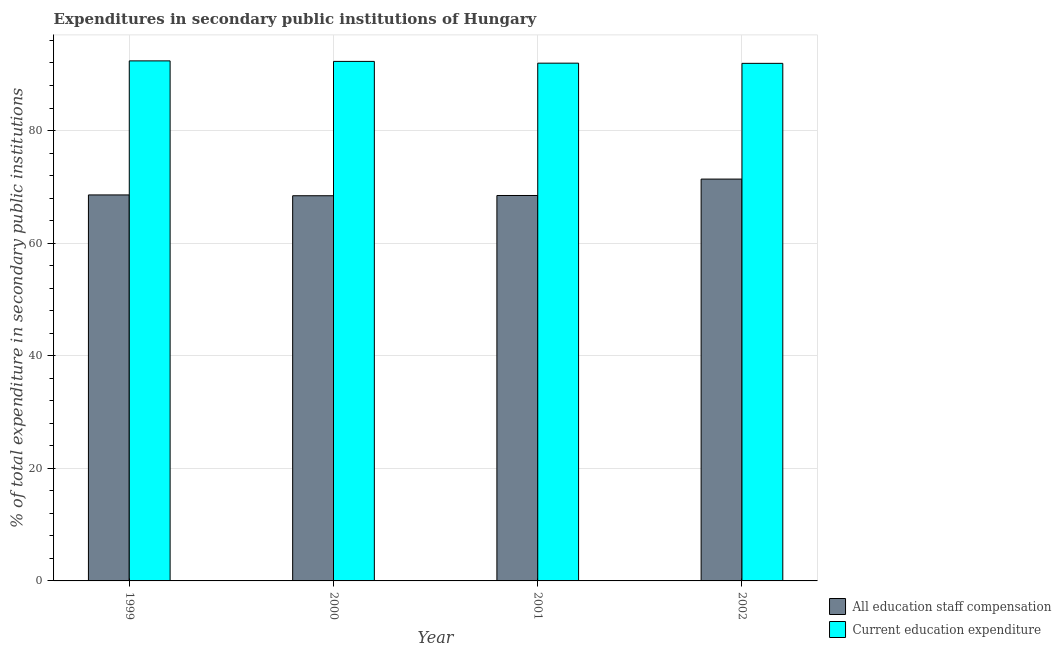How many different coloured bars are there?
Ensure brevity in your answer.  2. How many groups of bars are there?
Give a very brief answer. 4. How many bars are there on the 1st tick from the left?
Provide a succinct answer. 2. How many bars are there on the 1st tick from the right?
Provide a succinct answer. 2. What is the label of the 1st group of bars from the left?
Your answer should be very brief. 1999. In how many cases, is the number of bars for a given year not equal to the number of legend labels?
Your answer should be very brief. 0. What is the expenditure in staff compensation in 2001?
Offer a terse response. 68.46. Across all years, what is the maximum expenditure in staff compensation?
Ensure brevity in your answer.  71.38. Across all years, what is the minimum expenditure in staff compensation?
Provide a short and direct response. 68.42. What is the total expenditure in staff compensation in the graph?
Offer a very short reply. 276.83. What is the difference between the expenditure in education in 1999 and that in 2001?
Your response must be concise. 0.41. What is the difference between the expenditure in staff compensation in 2000 and the expenditure in education in 2001?
Keep it short and to the point. -0.04. What is the average expenditure in education per year?
Provide a short and direct response. 92.14. In the year 2001, what is the difference between the expenditure in staff compensation and expenditure in education?
Offer a terse response. 0. What is the ratio of the expenditure in staff compensation in 1999 to that in 2002?
Keep it short and to the point. 0.96. Is the difference between the expenditure in staff compensation in 1999 and 2001 greater than the difference between the expenditure in education in 1999 and 2001?
Offer a very short reply. No. What is the difference between the highest and the second highest expenditure in staff compensation?
Give a very brief answer. 2.81. What is the difference between the highest and the lowest expenditure in staff compensation?
Ensure brevity in your answer.  2.96. What does the 1st bar from the left in 1999 represents?
Make the answer very short. All education staff compensation. What does the 2nd bar from the right in 1999 represents?
Your answer should be compact. All education staff compensation. How many years are there in the graph?
Offer a very short reply. 4. Does the graph contain any zero values?
Offer a terse response. No. Does the graph contain grids?
Provide a succinct answer. Yes. How are the legend labels stacked?
Make the answer very short. Vertical. What is the title of the graph?
Give a very brief answer. Expenditures in secondary public institutions of Hungary. What is the label or title of the Y-axis?
Your response must be concise. % of total expenditure in secondary public institutions. What is the % of total expenditure in secondary public institutions of All education staff compensation in 1999?
Ensure brevity in your answer.  68.57. What is the % of total expenditure in secondary public institutions of Current education expenditure in 1999?
Offer a terse response. 92.38. What is the % of total expenditure in secondary public institutions in All education staff compensation in 2000?
Your answer should be compact. 68.42. What is the % of total expenditure in secondary public institutions in Current education expenditure in 2000?
Ensure brevity in your answer.  92.28. What is the % of total expenditure in secondary public institutions of All education staff compensation in 2001?
Make the answer very short. 68.46. What is the % of total expenditure in secondary public institutions of Current education expenditure in 2001?
Make the answer very short. 91.97. What is the % of total expenditure in secondary public institutions of All education staff compensation in 2002?
Make the answer very short. 71.38. What is the % of total expenditure in secondary public institutions of Current education expenditure in 2002?
Give a very brief answer. 91.94. Across all years, what is the maximum % of total expenditure in secondary public institutions in All education staff compensation?
Provide a succinct answer. 71.38. Across all years, what is the maximum % of total expenditure in secondary public institutions in Current education expenditure?
Offer a terse response. 92.38. Across all years, what is the minimum % of total expenditure in secondary public institutions in All education staff compensation?
Give a very brief answer. 68.42. Across all years, what is the minimum % of total expenditure in secondary public institutions in Current education expenditure?
Your answer should be compact. 91.94. What is the total % of total expenditure in secondary public institutions in All education staff compensation in the graph?
Keep it short and to the point. 276.83. What is the total % of total expenditure in secondary public institutions of Current education expenditure in the graph?
Your answer should be compact. 368.56. What is the difference between the % of total expenditure in secondary public institutions in All education staff compensation in 1999 and that in 2000?
Keep it short and to the point. 0.14. What is the difference between the % of total expenditure in secondary public institutions in Current education expenditure in 1999 and that in 2000?
Offer a terse response. 0.09. What is the difference between the % of total expenditure in secondary public institutions of All education staff compensation in 1999 and that in 2001?
Provide a succinct answer. 0.1. What is the difference between the % of total expenditure in secondary public institutions in Current education expenditure in 1999 and that in 2001?
Ensure brevity in your answer.  0.41. What is the difference between the % of total expenditure in secondary public institutions in All education staff compensation in 1999 and that in 2002?
Offer a very short reply. -2.81. What is the difference between the % of total expenditure in secondary public institutions in Current education expenditure in 1999 and that in 2002?
Make the answer very short. 0.44. What is the difference between the % of total expenditure in secondary public institutions of All education staff compensation in 2000 and that in 2001?
Your answer should be very brief. -0.04. What is the difference between the % of total expenditure in secondary public institutions in Current education expenditure in 2000 and that in 2001?
Give a very brief answer. 0.31. What is the difference between the % of total expenditure in secondary public institutions in All education staff compensation in 2000 and that in 2002?
Offer a very short reply. -2.96. What is the difference between the % of total expenditure in secondary public institutions of Current education expenditure in 2000 and that in 2002?
Offer a terse response. 0.35. What is the difference between the % of total expenditure in secondary public institutions of All education staff compensation in 2001 and that in 2002?
Give a very brief answer. -2.92. What is the difference between the % of total expenditure in secondary public institutions in Current education expenditure in 2001 and that in 2002?
Give a very brief answer. 0.03. What is the difference between the % of total expenditure in secondary public institutions in All education staff compensation in 1999 and the % of total expenditure in secondary public institutions in Current education expenditure in 2000?
Provide a succinct answer. -23.72. What is the difference between the % of total expenditure in secondary public institutions in All education staff compensation in 1999 and the % of total expenditure in secondary public institutions in Current education expenditure in 2001?
Ensure brevity in your answer.  -23.4. What is the difference between the % of total expenditure in secondary public institutions in All education staff compensation in 1999 and the % of total expenditure in secondary public institutions in Current education expenditure in 2002?
Ensure brevity in your answer.  -23.37. What is the difference between the % of total expenditure in secondary public institutions in All education staff compensation in 2000 and the % of total expenditure in secondary public institutions in Current education expenditure in 2001?
Your answer should be very brief. -23.55. What is the difference between the % of total expenditure in secondary public institutions in All education staff compensation in 2000 and the % of total expenditure in secondary public institutions in Current education expenditure in 2002?
Give a very brief answer. -23.51. What is the difference between the % of total expenditure in secondary public institutions of All education staff compensation in 2001 and the % of total expenditure in secondary public institutions of Current education expenditure in 2002?
Make the answer very short. -23.47. What is the average % of total expenditure in secondary public institutions in All education staff compensation per year?
Provide a short and direct response. 69.21. What is the average % of total expenditure in secondary public institutions in Current education expenditure per year?
Ensure brevity in your answer.  92.14. In the year 1999, what is the difference between the % of total expenditure in secondary public institutions of All education staff compensation and % of total expenditure in secondary public institutions of Current education expenditure?
Make the answer very short. -23.81. In the year 2000, what is the difference between the % of total expenditure in secondary public institutions of All education staff compensation and % of total expenditure in secondary public institutions of Current education expenditure?
Your answer should be compact. -23.86. In the year 2001, what is the difference between the % of total expenditure in secondary public institutions in All education staff compensation and % of total expenditure in secondary public institutions in Current education expenditure?
Your answer should be very brief. -23.51. In the year 2002, what is the difference between the % of total expenditure in secondary public institutions of All education staff compensation and % of total expenditure in secondary public institutions of Current education expenditure?
Make the answer very short. -20.56. What is the ratio of the % of total expenditure in secondary public institutions in All education staff compensation in 1999 to that in 2001?
Your answer should be very brief. 1. What is the ratio of the % of total expenditure in secondary public institutions of Current education expenditure in 1999 to that in 2001?
Offer a very short reply. 1. What is the ratio of the % of total expenditure in secondary public institutions of All education staff compensation in 1999 to that in 2002?
Your answer should be compact. 0.96. What is the ratio of the % of total expenditure in secondary public institutions of All education staff compensation in 2000 to that in 2001?
Provide a short and direct response. 1. What is the ratio of the % of total expenditure in secondary public institutions in Current education expenditure in 2000 to that in 2001?
Offer a terse response. 1. What is the ratio of the % of total expenditure in secondary public institutions in All education staff compensation in 2000 to that in 2002?
Your answer should be compact. 0.96. What is the ratio of the % of total expenditure in secondary public institutions of Current education expenditure in 2000 to that in 2002?
Your answer should be compact. 1. What is the ratio of the % of total expenditure in secondary public institutions of All education staff compensation in 2001 to that in 2002?
Offer a terse response. 0.96. What is the difference between the highest and the second highest % of total expenditure in secondary public institutions of All education staff compensation?
Your answer should be very brief. 2.81. What is the difference between the highest and the second highest % of total expenditure in secondary public institutions of Current education expenditure?
Ensure brevity in your answer.  0.09. What is the difference between the highest and the lowest % of total expenditure in secondary public institutions in All education staff compensation?
Give a very brief answer. 2.96. What is the difference between the highest and the lowest % of total expenditure in secondary public institutions in Current education expenditure?
Offer a terse response. 0.44. 